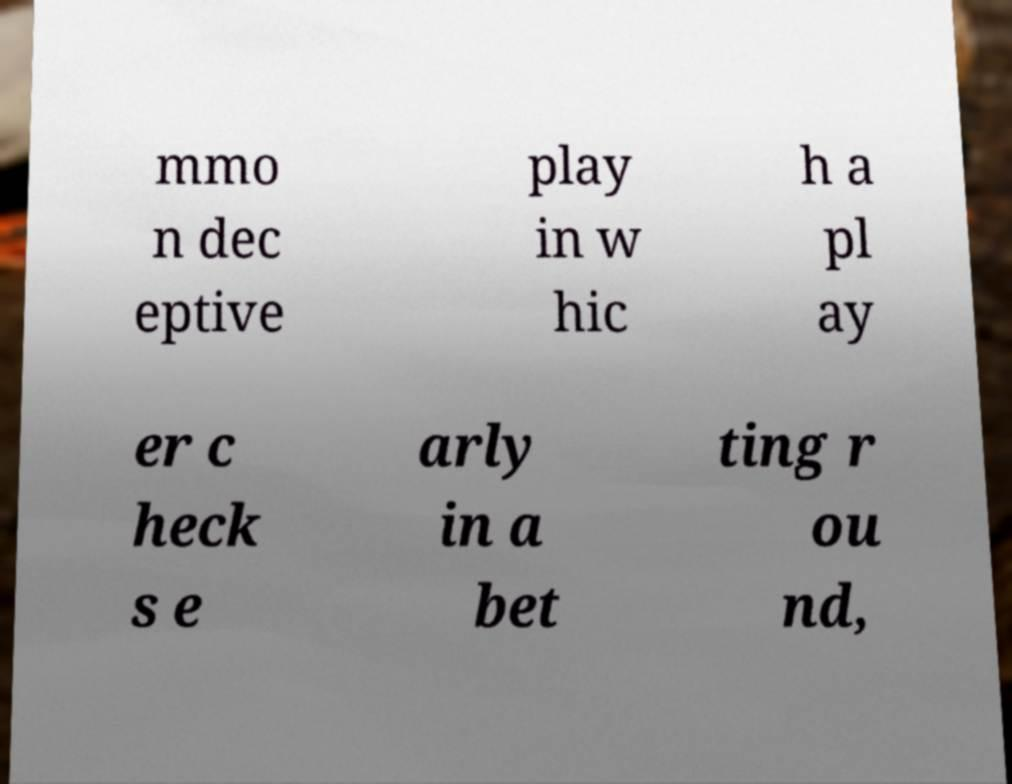Please identify and transcribe the text found in this image. mmo n dec eptive play in w hic h a pl ay er c heck s e arly in a bet ting r ou nd, 